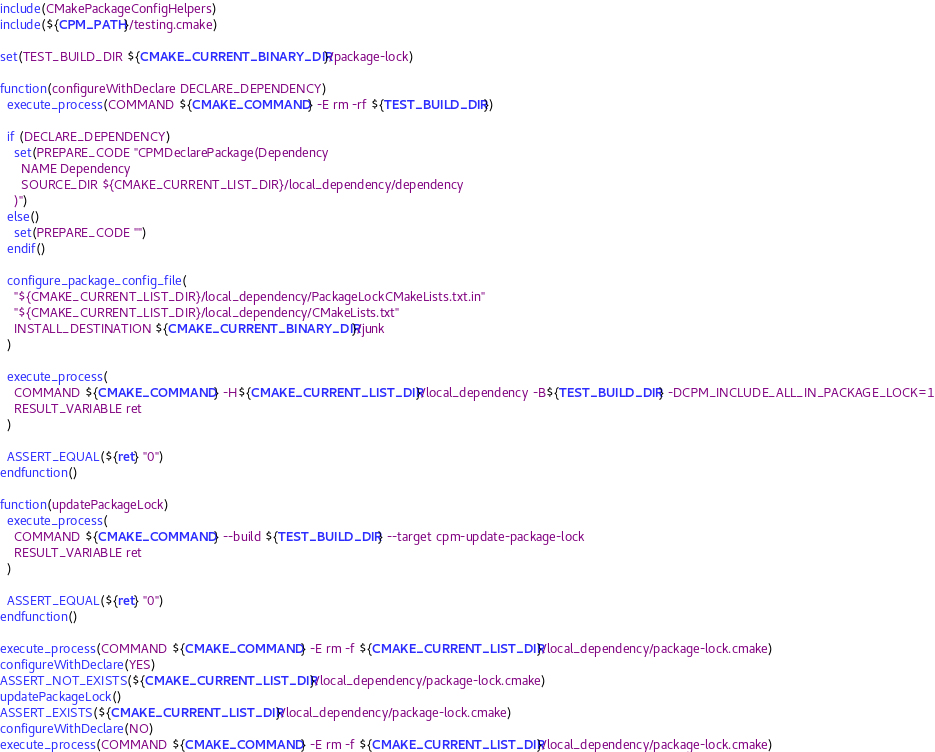<code> <loc_0><loc_0><loc_500><loc_500><_CMake_>
include(CMakePackageConfigHelpers)
include(${CPM_PATH}/testing.cmake)

set(TEST_BUILD_DIR ${CMAKE_CURRENT_BINARY_DIR}/package-lock)

function(configureWithDeclare DECLARE_DEPENDENCY)
  execute_process(COMMAND ${CMAKE_COMMAND} -E rm -rf ${TEST_BUILD_DIR})

  if (DECLARE_DEPENDENCY)
    set(PREPARE_CODE "CPMDeclarePackage(Dependency
      NAME Dependency 
      SOURCE_DIR ${CMAKE_CURRENT_LIST_DIR}/local_dependency/dependency
    )")
  else()
    set(PREPARE_CODE "")
  endif()

  configure_package_config_file(
    "${CMAKE_CURRENT_LIST_DIR}/local_dependency/PackageLockCMakeLists.txt.in"
    "${CMAKE_CURRENT_LIST_DIR}/local_dependency/CMakeLists.txt"
    INSTALL_DESTINATION ${CMAKE_CURRENT_BINARY_DIR}/junk
  )

  execute_process(
    COMMAND ${CMAKE_COMMAND} -H${CMAKE_CURRENT_LIST_DIR}/local_dependency -B${TEST_BUILD_DIR} -DCPM_INCLUDE_ALL_IN_PACKAGE_LOCK=1
    RESULT_VARIABLE ret
  )

  ASSERT_EQUAL(${ret} "0")
endfunction()

function(updatePackageLock)
  execute_process(
    COMMAND ${CMAKE_COMMAND} --build ${TEST_BUILD_DIR} --target cpm-update-package-lock
    RESULT_VARIABLE ret
  )

  ASSERT_EQUAL(${ret} "0")
endfunction()

execute_process(COMMAND ${CMAKE_COMMAND} -E rm -f ${CMAKE_CURRENT_LIST_DIR}/local_dependency/package-lock.cmake)
configureWithDeclare(YES)
ASSERT_NOT_EXISTS(${CMAKE_CURRENT_LIST_DIR}/local_dependency/package-lock.cmake)
updatePackageLock()
ASSERT_EXISTS(${CMAKE_CURRENT_LIST_DIR}/local_dependency/package-lock.cmake)
configureWithDeclare(NO)
execute_process(COMMAND ${CMAKE_COMMAND} -E rm -f ${CMAKE_CURRENT_LIST_DIR}/local_dependency/package-lock.cmake)

</code> 